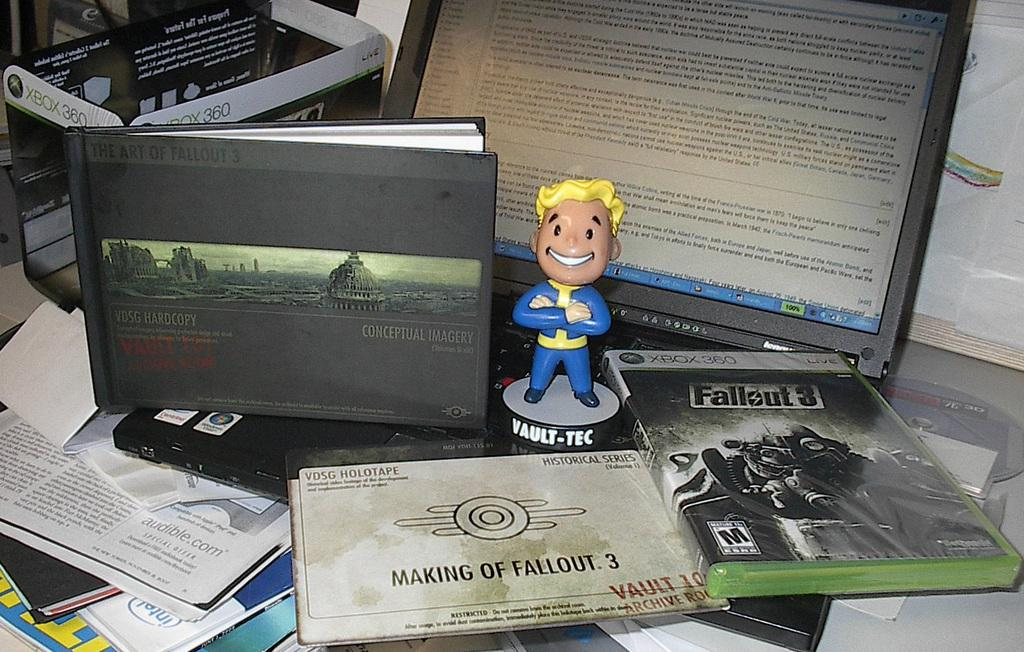<image>
Offer a succinct explanation of the picture presented. A computer sits with books and a game called Fallout 3. 